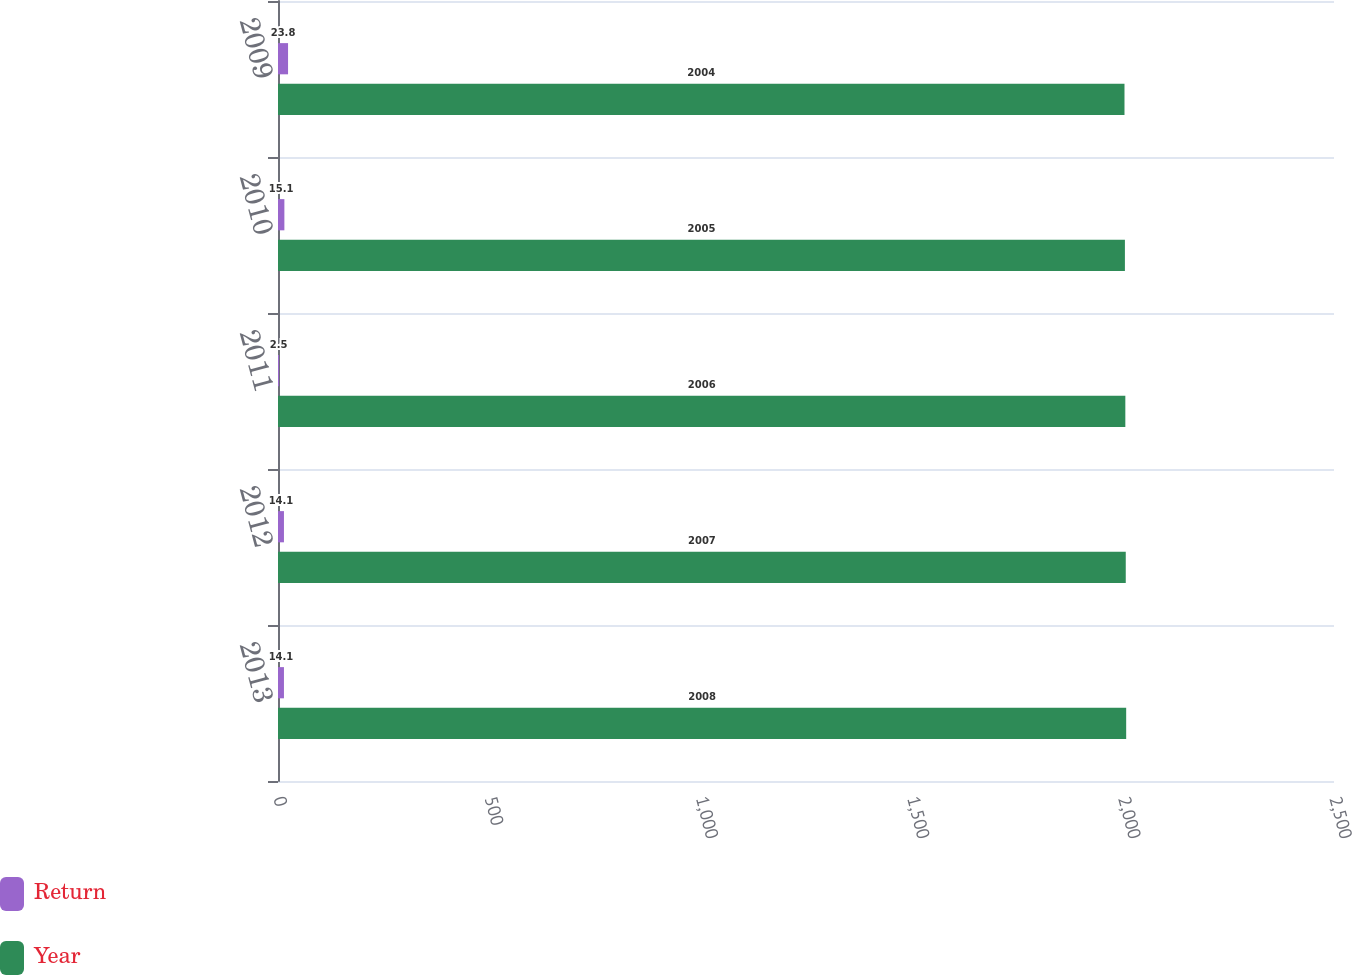Convert chart to OTSL. <chart><loc_0><loc_0><loc_500><loc_500><stacked_bar_chart><ecel><fcel>2013<fcel>2012<fcel>2011<fcel>2010<fcel>2009<nl><fcel>Return<fcel>14.1<fcel>14.1<fcel>2.5<fcel>15.1<fcel>23.8<nl><fcel>Year<fcel>2008<fcel>2007<fcel>2006<fcel>2005<fcel>2004<nl></chart> 